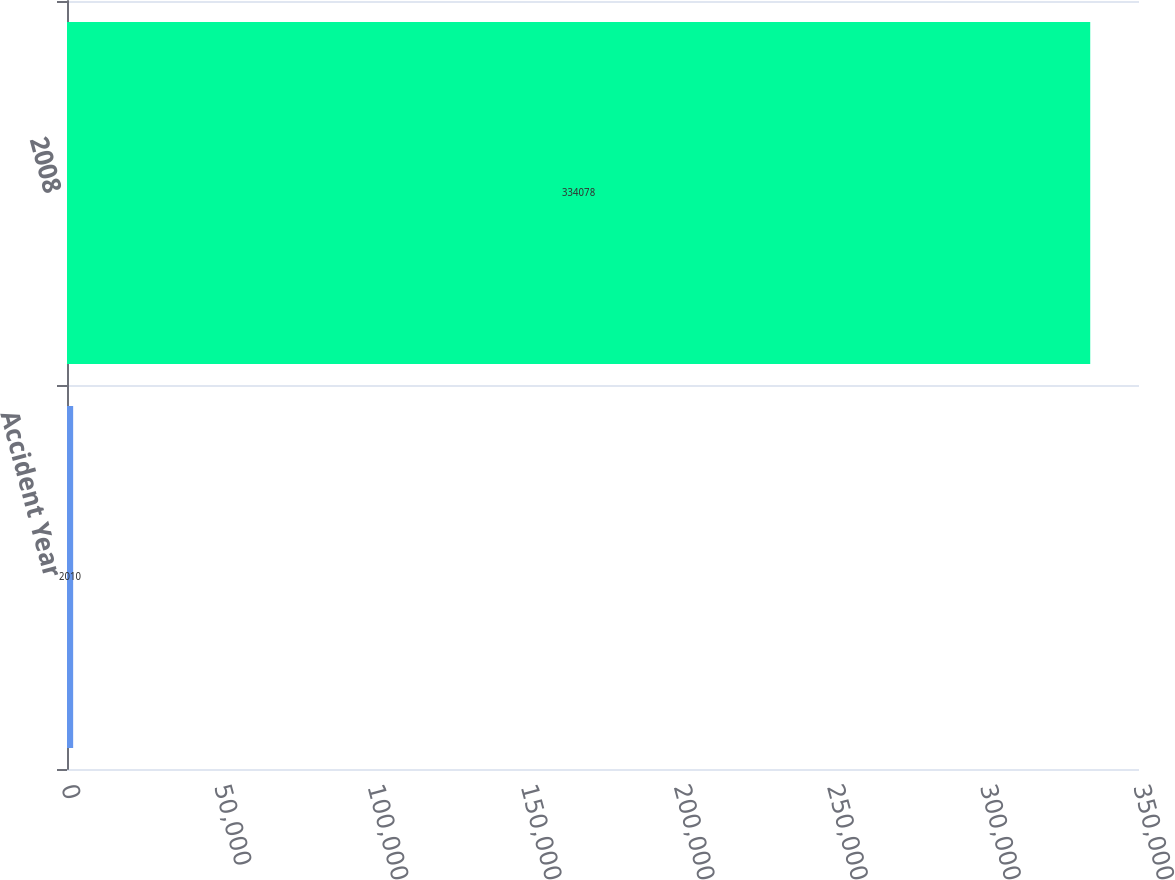Convert chart to OTSL. <chart><loc_0><loc_0><loc_500><loc_500><bar_chart><fcel>Accident Year<fcel>2008<nl><fcel>2010<fcel>334078<nl></chart> 